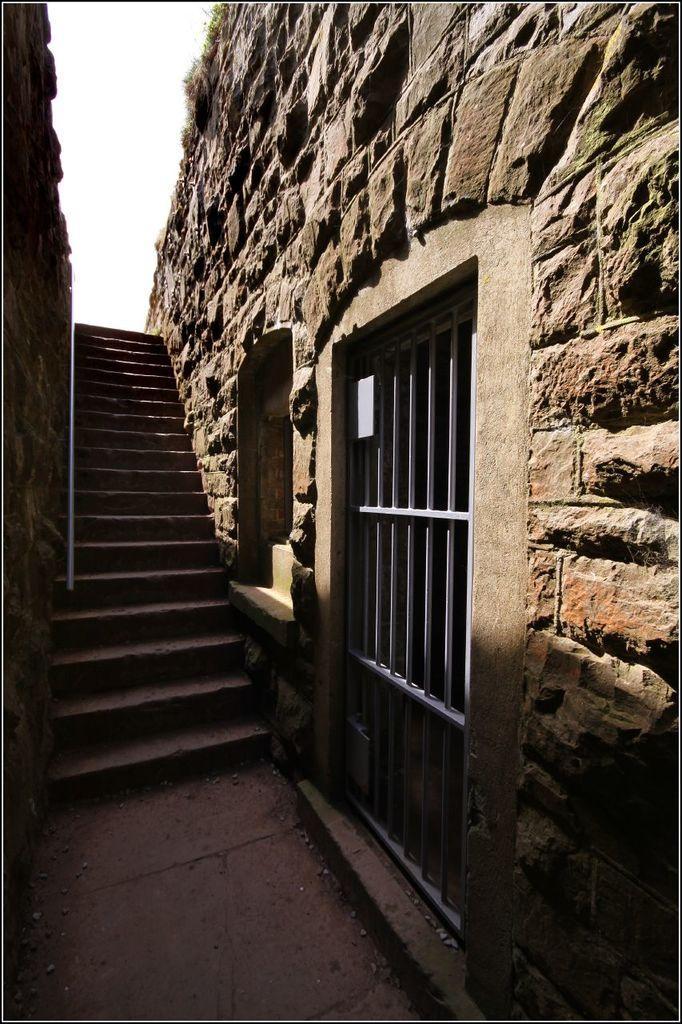How would you summarize this image in a sentence or two? In this image there is a staircase. Both sides of it there is wall. Right side there is a metal gate. Beside there is window to the wall. Top of image there is sky. 